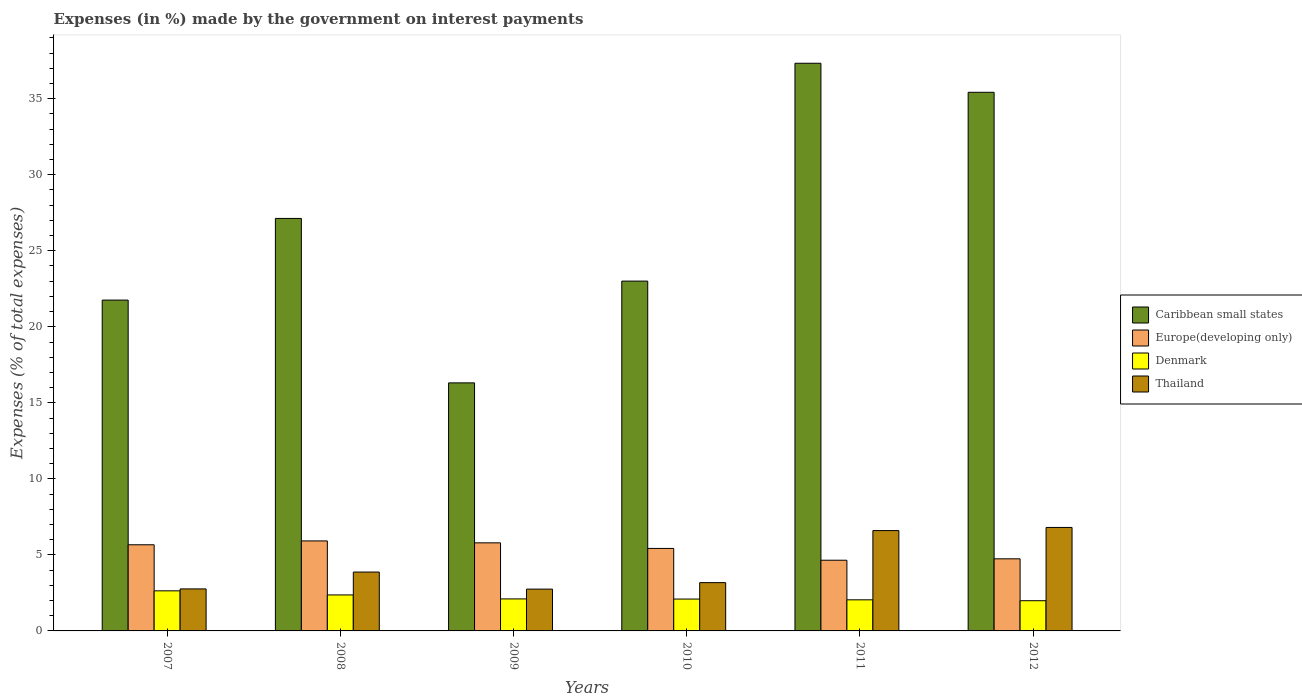How many different coloured bars are there?
Give a very brief answer. 4. Are the number of bars per tick equal to the number of legend labels?
Your response must be concise. Yes. Are the number of bars on each tick of the X-axis equal?
Your answer should be very brief. Yes. In how many cases, is the number of bars for a given year not equal to the number of legend labels?
Your answer should be compact. 0. What is the percentage of expenses made by the government on interest payments in Thailand in 2011?
Provide a short and direct response. 6.6. Across all years, what is the maximum percentage of expenses made by the government on interest payments in Denmark?
Offer a very short reply. 2.64. Across all years, what is the minimum percentage of expenses made by the government on interest payments in Denmark?
Keep it short and to the point. 1.99. In which year was the percentage of expenses made by the government on interest payments in Caribbean small states maximum?
Your response must be concise. 2011. What is the total percentage of expenses made by the government on interest payments in Europe(developing only) in the graph?
Make the answer very short. 32.19. What is the difference between the percentage of expenses made by the government on interest payments in Caribbean small states in 2008 and that in 2012?
Offer a very short reply. -8.29. What is the difference between the percentage of expenses made by the government on interest payments in Caribbean small states in 2007 and the percentage of expenses made by the government on interest payments in Europe(developing only) in 2009?
Ensure brevity in your answer.  15.96. What is the average percentage of expenses made by the government on interest payments in Caribbean small states per year?
Offer a very short reply. 26.83. In the year 2008, what is the difference between the percentage of expenses made by the government on interest payments in Europe(developing only) and percentage of expenses made by the government on interest payments in Denmark?
Your answer should be very brief. 3.55. In how many years, is the percentage of expenses made by the government on interest payments in Denmark greater than 34 %?
Provide a succinct answer. 0. What is the ratio of the percentage of expenses made by the government on interest payments in Europe(developing only) in 2007 to that in 2012?
Provide a short and direct response. 1.19. Is the percentage of expenses made by the government on interest payments in Europe(developing only) in 2008 less than that in 2009?
Offer a very short reply. No. What is the difference between the highest and the second highest percentage of expenses made by the government on interest payments in Denmark?
Your answer should be very brief. 0.27. What is the difference between the highest and the lowest percentage of expenses made by the government on interest payments in Caribbean small states?
Your response must be concise. 21.02. In how many years, is the percentage of expenses made by the government on interest payments in Europe(developing only) greater than the average percentage of expenses made by the government on interest payments in Europe(developing only) taken over all years?
Provide a succinct answer. 4. Is it the case that in every year, the sum of the percentage of expenses made by the government on interest payments in Caribbean small states and percentage of expenses made by the government on interest payments in Denmark is greater than the sum of percentage of expenses made by the government on interest payments in Thailand and percentage of expenses made by the government on interest payments in Europe(developing only)?
Give a very brief answer. Yes. What does the 3rd bar from the right in 2007 represents?
Offer a terse response. Europe(developing only). Is it the case that in every year, the sum of the percentage of expenses made by the government on interest payments in Thailand and percentage of expenses made by the government on interest payments in Denmark is greater than the percentage of expenses made by the government on interest payments in Europe(developing only)?
Make the answer very short. No. Are all the bars in the graph horizontal?
Give a very brief answer. No. How many years are there in the graph?
Offer a terse response. 6. Does the graph contain any zero values?
Your answer should be very brief. No. Where does the legend appear in the graph?
Ensure brevity in your answer.  Center right. What is the title of the graph?
Keep it short and to the point. Expenses (in %) made by the government on interest payments. Does "Malaysia" appear as one of the legend labels in the graph?
Make the answer very short. No. What is the label or title of the X-axis?
Ensure brevity in your answer.  Years. What is the label or title of the Y-axis?
Your answer should be very brief. Expenses (% of total expenses). What is the Expenses (% of total expenses) of Caribbean small states in 2007?
Keep it short and to the point. 21.76. What is the Expenses (% of total expenses) in Europe(developing only) in 2007?
Keep it short and to the point. 5.66. What is the Expenses (% of total expenses) in Denmark in 2007?
Provide a succinct answer. 2.64. What is the Expenses (% of total expenses) in Thailand in 2007?
Your answer should be very brief. 2.76. What is the Expenses (% of total expenses) of Caribbean small states in 2008?
Ensure brevity in your answer.  27.13. What is the Expenses (% of total expenses) of Europe(developing only) in 2008?
Make the answer very short. 5.92. What is the Expenses (% of total expenses) of Denmark in 2008?
Your answer should be very brief. 2.37. What is the Expenses (% of total expenses) of Thailand in 2008?
Provide a succinct answer. 3.87. What is the Expenses (% of total expenses) in Caribbean small states in 2009?
Offer a very short reply. 16.31. What is the Expenses (% of total expenses) of Europe(developing only) in 2009?
Ensure brevity in your answer.  5.79. What is the Expenses (% of total expenses) in Denmark in 2009?
Give a very brief answer. 2.1. What is the Expenses (% of total expenses) of Thailand in 2009?
Provide a succinct answer. 2.75. What is the Expenses (% of total expenses) in Caribbean small states in 2010?
Keep it short and to the point. 23.01. What is the Expenses (% of total expenses) in Europe(developing only) in 2010?
Offer a terse response. 5.42. What is the Expenses (% of total expenses) in Denmark in 2010?
Keep it short and to the point. 2.1. What is the Expenses (% of total expenses) of Thailand in 2010?
Provide a short and direct response. 3.18. What is the Expenses (% of total expenses) in Caribbean small states in 2011?
Your answer should be very brief. 37.33. What is the Expenses (% of total expenses) of Europe(developing only) in 2011?
Keep it short and to the point. 4.65. What is the Expenses (% of total expenses) in Denmark in 2011?
Keep it short and to the point. 2.04. What is the Expenses (% of total expenses) of Thailand in 2011?
Your answer should be compact. 6.6. What is the Expenses (% of total expenses) of Caribbean small states in 2012?
Ensure brevity in your answer.  35.42. What is the Expenses (% of total expenses) of Europe(developing only) in 2012?
Give a very brief answer. 4.74. What is the Expenses (% of total expenses) of Denmark in 2012?
Provide a short and direct response. 1.99. What is the Expenses (% of total expenses) of Thailand in 2012?
Keep it short and to the point. 6.81. Across all years, what is the maximum Expenses (% of total expenses) of Caribbean small states?
Your response must be concise. 37.33. Across all years, what is the maximum Expenses (% of total expenses) in Europe(developing only)?
Offer a very short reply. 5.92. Across all years, what is the maximum Expenses (% of total expenses) in Denmark?
Give a very brief answer. 2.64. Across all years, what is the maximum Expenses (% of total expenses) in Thailand?
Your response must be concise. 6.81. Across all years, what is the minimum Expenses (% of total expenses) in Caribbean small states?
Your answer should be very brief. 16.31. Across all years, what is the minimum Expenses (% of total expenses) in Europe(developing only)?
Offer a very short reply. 4.65. Across all years, what is the minimum Expenses (% of total expenses) in Denmark?
Provide a succinct answer. 1.99. Across all years, what is the minimum Expenses (% of total expenses) in Thailand?
Keep it short and to the point. 2.75. What is the total Expenses (% of total expenses) of Caribbean small states in the graph?
Your answer should be very brief. 160.95. What is the total Expenses (% of total expenses) of Europe(developing only) in the graph?
Keep it short and to the point. 32.19. What is the total Expenses (% of total expenses) of Denmark in the graph?
Give a very brief answer. 13.23. What is the total Expenses (% of total expenses) in Thailand in the graph?
Make the answer very short. 25.96. What is the difference between the Expenses (% of total expenses) of Caribbean small states in 2007 and that in 2008?
Offer a terse response. -5.37. What is the difference between the Expenses (% of total expenses) of Europe(developing only) in 2007 and that in 2008?
Ensure brevity in your answer.  -0.25. What is the difference between the Expenses (% of total expenses) of Denmark in 2007 and that in 2008?
Give a very brief answer. 0.27. What is the difference between the Expenses (% of total expenses) in Thailand in 2007 and that in 2008?
Keep it short and to the point. -1.11. What is the difference between the Expenses (% of total expenses) of Caribbean small states in 2007 and that in 2009?
Offer a terse response. 5.44. What is the difference between the Expenses (% of total expenses) in Europe(developing only) in 2007 and that in 2009?
Your response must be concise. -0.13. What is the difference between the Expenses (% of total expenses) in Denmark in 2007 and that in 2009?
Ensure brevity in your answer.  0.53. What is the difference between the Expenses (% of total expenses) in Thailand in 2007 and that in 2009?
Make the answer very short. 0.01. What is the difference between the Expenses (% of total expenses) in Caribbean small states in 2007 and that in 2010?
Keep it short and to the point. -1.25. What is the difference between the Expenses (% of total expenses) of Europe(developing only) in 2007 and that in 2010?
Offer a very short reply. 0.24. What is the difference between the Expenses (% of total expenses) of Denmark in 2007 and that in 2010?
Offer a very short reply. 0.54. What is the difference between the Expenses (% of total expenses) in Thailand in 2007 and that in 2010?
Ensure brevity in your answer.  -0.41. What is the difference between the Expenses (% of total expenses) of Caribbean small states in 2007 and that in 2011?
Keep it short and to the point. -15.57. What is the difference between the Expenses (% of total expenses) of Europe(developing only) in 2007 and that in 2011?
Make the answer very short. 1.02. What is the difference between the Expenses (% of total expenses) of Denmark in 2007 and that in 2011?
Your response must be concise. 0.59. What is the difference between the Expenses (% of total expenses) in Thailand in 2007 and that in 2011?
Provide a short and direct response. -3.84. What is the difference between the Expenses (% of total expenses) of Caribbean small states in 2007 and that in 2012?
Your answer should be very brief. -13.66. What is the difference between the Expenses (% of total expenses) in Europe(developing only) in 2007 and that in 2012?
Provide a succinct answer. 0.92. What is the difference between the Expenses (% of total expenses) in Denmark in 2007 and that in 2012?
Offer a terse response. 0.65. What is the difference between the Expenses (% of total expenses) in Thailand in 2007 and that in 2012?
Ensure brevity in your answer.  -4.04. What is the difference between the Expenses (% of total expenses) of Caribbean small states in 2008 and that in 2009?
Give a very brief answer. 10.81. What is the difference between the Expenses (% of total expenses) of Europe(developing only) in 2008 and that in 2009?
Provide a succinct answer. 0.13. What is the difference between the Expenses (% of total expenses) of Denmark in 2008 and that in 2009?
Keep it short and to the point. 0.26. What is the difference between the Expenses (% of total expenses) of Thailand in 2008 and that in 2009?
Make the answer very short. 1.12. What is the difference between the Expenses (% of total expenses) of Caribbean small states in 2008 and that in 2010?
Provide a succinct answer. 4.12. What is the difference between the Expenses (% of total expenses) in Europe(developing only) in 2008 and that in 2010?
Give a very brief answer. 0.5. What is the difference between the Expenses (% of total expenses) in Denmark in 2008 and that in 2010?
Give a very brief answer. 0.27. What is the difference between the Expenses (% of total expenses) in Thailand in 2008 and that in 2010?
Keep it short and to the point. 0.7. What is the difference between the Expenses (% of total expenses) in Caribbean small states in 2008 and that in 2011?
Offer a very short reply. -10.2. What is the difference between the Expenses (% of total expenses) in Europe(developing only) in 2008 and that in 2011?
Your answer should be very brief. 1.27. What is the difference between the Expenses (% of total expenses) of Denmark in 2008 and that in 2011?
Make the answer very short. 0.32. What is the difference between the Expenses (% of total expenses) of Thailand in 2008 and that in 2011?
Make the answer very short. -2.73. What is the difference between the Expenses (% of total expenses) in Caribbean small states in 2008 and that in 2012?
Make the answer very short. -8.29. What is the difference between the Expenses (% of total expenses) of Europe(developing only) in 2008 and that in 2012?
Give a very brief answer. 1.18. What is the difference between the Expenses (% of total expenses) in Denmark in 2008 and that in 2012?
Your response must be concise. 0.38. What is the difference between the Expenses (% of total expenses) of Thailand in 2008 and that in 2012?
Provide a succinct answer. -2.93. What is the difference between the Expenses (% of total expenses) in Caribbean small states in 2009 and that in 2010?
Offer a terse response. -6.69. What is the difference between the Expenses (% of total expenses) of Europe(developing only) in 2009 and that in 2010?
Make the answer very short. 0.37. What is the difference between the Expenses (% of total expenses) of Denmark in 2009 and that in 2010?
Offer a terse response. 0.01. What is the difference between the Expenses (% of total expenses) of Thailand in 2009 and that in 2010?
Provide a succinct answer. -0.43. What is the difference between the Expenses (% of total expenses) in Caribbean small states in 2009 and that in 2011?
Ensure brevity in your answer.  -21.02. What is the difference between the Expenses (% of total expenses) in Europe(developing only) in 2009 and that in 2011?
Your response must be concise. 1.14. What is the difference between the Expenses (% of total expenses) of Thailand in 2009 and that in 2011?
Provide a succinct answer. -3.85. What is the difference between the Expenses (% of total expenses) in Caribbean small states in 2009 and that in 2012?
Offer a terse response. -19.11. What is the difference between the Expenses (% of total expenses) of Europe(developing only) in 2009 and that in 2012?
Your response must be concise. 1.05. What is the difference between the Expenses (% of total expenses) of Denmark in 2009 and that in 2012?
Ensure brevity in your answer.  0.12. What is the difference between the Expenses (% of total expenses) of Thailand in 2009 and that in 2012?
Offer a terse response. -4.06. What is the difference between the Expenses (% of total expenses) in Caribbean small states in 2010 and that in 2011?
Offer a very short reply. -14.33. What is the difference between the Expenses (% of total expenses) of Europe(developing only) in 2010 and that in 2011?
Provide a succinct answer. 0.78. What is the difference between the Expenses (% of total expenses) in Denmark in 2010 and that in 2011?
Your answer should be very brief. 0.05. What is the difference between the Expenses (% of total expenses) of Thailand in 2010 and that in 2011?
Give a very brief answer. -3.42. What is the difference between the Expenses (% of total expenses) in Caribbean small states in 2010 and that in 2012?
Provide a short and direct response. -12.42. What is the difference between the Expenses (% of total expenses) of Europe(developing only) in 2010 and that in 2012?
Provide a short and direct response. 0.68. What is the difference between the Expenses (% of total expenses) of Denmark in 2010 and that in 2012?
Offer a very short reply. 0.11. What is the difference between the Expenses (% of total expenses) of Thailand in 2010 and that in 2012?
Your answer should be compact. -3.63. What is the difference between the Expenses (% of total expenses) of Caribbean small states in 2011 and that in 2012?
Provide a succinct answer. 1.91. What is the difference between the Expenses (% of total expenses) of Europe(developing only) in 2011 and that in 2012?
Make the answer very short. -0.09. What is the difference between the Expenses (% of total expenses) in Denmark in 2011 and that in 2012?
Offer a very short reply. 0.06. What is the difference between the Expenses (% of total expenses) in Thailand in 2011 and that in 2012?
Your answer should be compact. -0.21. What is the difference between the Expenses (% of total expenses) of Caribbean small states in 2007 and the Expenses (% of total expenses) of Europe(developing only) in 2008?
Provide a short and direct response. 15.84. What is the difference between the Expenses (% of total expenses) of Caribbean small states in 2007 and the Expenses (% of total expenses) of Denmark in 2008?
Offer a terse response. 19.39. What is the difference between the Expenses (% of total expenses) in Caribbean small states in 2007 and the Expenses (% of total expenses) in Thailand in 2008?
Your response must be concise. 17.89. What is the difference between the Expenses (% of total expenses) of Europe(developing only) in 2007 and the Expenses (% of total expenses) of Denmark in 2008?
Give a very brief answer. 3.3. What is the difference between the Expenses (% of total expenses) of Europe(developing only) in 2007 and the Expenses (% of total expenses) of Thailand in 2008?
Make the answer very short. 1.79. What is the difference between the Expenses (% of total expenses) of Denmark in 2007 and the Expenses (% of total expenses) of Thailand in 2008?
Give a very brief answer. -1.24. What is the difference between the Expenses (% of total expenses) of Caribbean small states in 2007 and the Expenses (% of total expenses) of Europe(developing only) in 2009?
Keep it short and to the point. 15.96. What is the difference between the Expenses (% of total expenses) of Caribbean small states in 2007 and the Expenses (% of total expenses) of Denmark in 2009?
Keep it short and to the point. 19.65. What is the difference between the Expenses (% of total expenses) in Caribbean small states in 2007 and the Expenses (% of total expenses) in Thailand in 2009?
Offer a very short reply. 19.01. What is the difference between the Expenses (% of total expenses) of Europe(developing only) in 2007 and the Expenses (% of total expenses) of Denmark in 2009?
Offer a terse response. 3.56. What is the difference between the Expenses (% of total expenses) in Europe(developing only) in 2007 and the Expenses (% of total expenses) in Thailand in 2009?
Provide a succinct answer. 2.92. What is the difference between the Expenses (% of total expenses) of Denmark in 2007 and the Expenses (% of total expenses) of Thailand in 2009?
Offer a terse response. -0.11. What is the difference between the Expenses (% of total expenses) in Caribbean small states in 2007 and the Expenses (% of total expenses) in Europe(developing only) in 2010?
Keep it short and to the point. 16.33. What is the difference between the Expenses (% of total expenses) in Caribbean small states in 2007 and the Expenses (% of total expenses) in Denmark in 2010?
Offer a very short reply. 19.66. What is the difference between the Expenses (% of total expenses) of Caribbean small states in 2007 and the Expenses (% of total expenses) of Thailand in 2010?
Keep it short and to the point. 18.58. What is the difference between the Expenses (% of total expenses) of Europe(developing only) in 2007 and the Expenses (% of total expenses) of Denmark in 2010?
Make the answer very short. 3.57. What is the difference between the Expenses (% of total expenses) in Europe(developing only) in 2007 and the Expenses (% of total expenses) in Thailand in 2010?
Offer a terse response. 2.49. What is the difference between the Expenses (% of total expenses) of Denmark in 2007 and the Expenses (% of total expenses) of Thailand in 2010?
Ensure brevity in your answer.  -0.54. What is the difference between the Expenses (% of total expenses) in Caribbean small states in 2007 and the Expenses (% of total expenses) in Europe(developing only) in 2011?
Keep it short and to the point. 17.11. What is the difference between the Expenses (% of total expenses) of Caribbean small states in 2007 and the Expenses (% of total expenses) of Denmark in 2011?
Provide a short and direct response. 19.71. What is the difference between the Expenses (% of total expenses) of Caribbean small states in 2007 and the Expenses (% of total expenses) of Thailand in 2011?
Offer a very short reply. 15.16. What is the difference between the Expenses (% of total expenses) of Europe(developing only) in 2007 and the Expenses (% of total expenses) of Denmark in 2011?
Offer a very short reply. 3.62. What is the difference between the Expenses (% of total expenses) of Europe(developing only) in 2007 and the Expenses (% of total expenses) of Thailand in 2011?
Keep it short and to the point. -0.93. What is the difference between the Expenses (% of total expenses) in Denmark in 2007 and the Expenses (% of total expenses) in Thailand in 2011?
Your answer should be compact. -3.96. What is the difference between the Expenses (% of total expenses) of Caribbean small states in 2007 and the Expenses (% of total expenses) of Europe(developing only) in 2012?
Your answer should be very brief. 17.01. What is the difference between the Expenses (% of total expenses) in Caribbean small states in 2007 and the Expenses (% of total expenses) in Denmark in 2012?
Offer a very short reply. 19.77. What is the difference between the Expenses (% of total expenses) of Caribbean small states in 2007 and the Expenses (% of total expenses) of Thailand in 2012?
Make the answer very short. 14.95. What is the difference between the Expenses (% of total expenses) in Europe(developing only) in 2007 and the Expenses (% of total expenses) in Denmark in 2012?
Your answer should be very brief. 3.68. What is the difference between the Expenses (% of total expenses) of Europe(developing only) in 2007 and the Expenses (% of total expenses) of Thailand in 2012?
Give a very brief answer. -1.14. What is the difference between the Expenses (% of total expenses) of Denmark in 2007 and the Expenses (% of total expenses) of Thailand in 2012?
Provide a short and direct response. -4.17. What is the difference between the Expenses (% of total expenses) in Caribbean small states in 2008 and the Expenses (% of total expenses) in Europe(developing only) in 2009?
Keep it short and to the point. 21.33. What is the difference between the Expenses (% of total expenses) of Caribbean small states in 2008 and the Expenses (% of total expenses) of Denmark in 2009?
Provide a succinct answer. 25.02. What is the difference between the Expenses (% of total expenses) of Caribbean small states in 2008 and the Expenses (% of total expenses) of Thailand in 2009?
Provide a succinct answer. 24.38. What is the difference between the Expenses (% of total expenses) in Europe(developing only) in 2008 and the Expenses (% of total expenses) in Denmark in 2009?
Ensure brevity in your answer.  3.81. What is the difference between the Expenses (% of total expenses) in Europe(developing only) in 2008 and the Expenses (% of total expenses) in Thailand in 2009?
Provide a succinct answer. 3.17. What is the difference between the Expenses (% of total expenses) in Denmark in 2008 and the Expenses (% of total expenses) in Thailand in 2009?
Ensure brevity in your answer.  -0.38. What is the difference between the Expenses (% of total expenses) in Caribbean small states in 2008 and the Expenses (% of total expenses) in Europe(developing only) in 2010?
Ensure brevity in your answer.  21.7. What is the difference between the Expenses (% of total expenses) of Caribbean small states in 2008 and the Expenses (% of total expenses) of Denmark in 2010?
Ensure brevity in your answer.  25.03. What is the difference between the Expenses (% of total expenses) in Caribbean small states in 2008 and the Expenses (% of total expenses) in Thailand in 2010?
Give a very brief answer. 23.95. What is the difference between the Expenses (% of total expenses) in Europe(developing only) in 2008 and the Expenses (% of total expenses) in Denmark in 2010?
Your answer should be compact. 3.82. What is the difference between the Expenses (% of total expenses) of Europe(developing only) in 2008 and the Expenses (% of total expenses) of Thailand in 2010?
Your response must be concise. 2.74. What is the difference between the Expenses (% of total expenses) in Denmark in 2008 and the Expenses (% of total expenses) in Thailand in 2010?
Ensure brevity in your answer.  -0.81. What is the difference between the Expenses (% of total expenses) of Caribbean small states in 2008 and the Expenses (% of total expenses) of Europe(developing only) in 2011?
Provide a succinct answer. 22.48. What is the difference between the Expenses (% of total expenses) of Caribbean small states in 2008 and the Expenses (% of total expenses) of Denmark in 2011?
Make the answer very short. 25.08. What is the difference between the Expenses (% of total expenses) in Caribbean small states in 2008 and the Expenses (% of total expenses) in Thailand in 2011?
Your answer should be compact. 20.53. What is the difference between the Expenses (% of total expenses) of Europe(developing only) in 2008 and the Expenses (% of total expenses) of Denmark in 2011?
Keep it short and to the point. 3.87. What is the difference between the Expenses (% of total expenses) in Europe(developing only) in 2008 and the Expenses (% of total expenses) in Thailand in 2011?
Make the answer very short. -0.68. What is the difference between the Expenses (% of total expenses) in Denmark in 2008 and the Expenses (% of total expenses) in Thailand in 2011?
Give a very brief answer. -4.23. What is the difference between the Expenses (% of total expenses) in Caribbean small states in 2008 and the Expenses (% of total expenses) in Europe(developing only) in 2012?
Give a very brief answer. 22.38. What is the difference between the Expenses (% of total expenses) of Caribbean small states in 2008 and the Expenses (% of total expenses) of Denmark in 2012?
Your answer should be very brief. 25.14. What is the difference between the Expenses (% of total expenses) in Caribbean small states in 2008 and the Expenses (% of total expenses) in Thailand in 2012?
Give a very brief answer. 20.32. What is the difference between the Expenses (% of total expenses) of Europe(developing only) in 2008 and the Expenses (% of total expenses) of Denmark in 2012?
Your answer should be very brief. 3.93. What is the difference between the Expenses (% of total expenses) of Europe(developing only) in 2008 and the Expenses (% of total expenses) of Thailand in 2012?
Keep it short and to the point. -0.89. What is the difference between the Expenses (% of total expenses) in Denmark in 2008 and the Expenses (% of total expenses) in Thailand in 2012?
Offer a terse response. -4.44. What is the difference between the Expenses (% of total expenses) in Caribbean small states in 2009 and the Expenses (% of total expenses) in Europe(developing only) in 2010?
Offer a terse response. 10.89. What is the difference between the Expenses (% of total expenses) in Caribbean small states in 2009 and the Expenses (% of total expenses) in Denmark in 2010?
Ensure brevity in your answer.  14.22. What is the difference between the Expenses (% of total expenses) in Caribbean small states in 2009 and the Expenses (% of total expenses) in Thailand in 2010?
Provide a short and direct response. 13.14. What is the difference between the Expenses (% of total expenses) in Europe(developing only) in 2009 and the Expenses (% of total expenses) in Denmark in 2010?
Make the answer very short. 3.7. What is the difference between the Expenses (% of total expenses) in Europe(developing only) in 2009 and the Expenses (% of total expenses) in Thailand in 2010?
Make the answer very short. 2.62. What is the difference between the Expenses (% of total expenses) of Denmark in 2009 and the Expenses (% of total expenses) of Thailand in 2010?
Ensure brevity in your answer.  -1.07. What is the difference between the Expenses (% of total expenses) of Caribbean small states in 2009 and the Expenses (% of total expenses) of Europe(developing only) in 2011?
Offer a very short reply. 11.66. What is the difference between the Expenses (% of total expenses) in Caribbean small states in 2009 and the Expenses (% of total expenses) in Denmark in 2011?
Provide a short and direct response. 14.27. What is the difference between the Expenses (% of total expenses) of Caribbean small states in 2009 and the Expenses (% of total expenses) of Thailand in 2011?
Provide a succinct answer. 9.71. What is the difference between the Expenses (% of total expenses) of Europe(developing only) in 2009 and the Expenses (% of total expenses) of Denmark in 2011?
Your answer should be compact. 3.75. What is the difference between the Expenses (% of total expenses) of Europe(developing only) in 2009 and the Expenses (% of total expenses) of Thailand in 2011?
Offer a terse response. -0.81. What is the difference between the Expenses (% of total expenses) in Denmark in 2009 and the Expenses (% of total expenses) in Thailand in 2011?
Offer a terse response. -4.49. What is the difference between the Expenses (% of total expenses) in Caribbean small states in 2009 and the Expenses (% of total expenses) in Europe(developing only) in 2012?
Make the answer very short. 11.57. What is the difference between the Expenses (% of total expenses) in Caribbean small states in 2009 and the Expenses (% of total expenses) in Denmark in 2012?
Offer a terse response. 14.33. What is the difference between the Expenses (% of total expenses) in Caribbean small states in 2009 and the Expenses (% of total expenses) in Thailand in 2012?
Provide a succinct answer. 9.51. What is the difference between the Expenses (% of total expenses) of Europe(developing only) in 2009 and the Expenses (% of total expenses) of Denmark in 2012?
Your response must be concise. 3.81. What is the difference between the Expenses (% of total expenses) in Europe(developing only) in 2009 and the Expenses (% of total expenses) in Thailand in 2012?
Ensure brevity in your answer.  -1.01. What is the difference between the Expenses (% of total expenses) of Denmark in 2009 and the Expenses (% of total expenses) of Thailand in 2012?
Keep it short and to the point. -4.7. What is the difference between the Expenses (% of total expenses) of Caribbean small states in 2010 and the Expenses (% of total expenses) of Europe(developing only) in 2011?
Ensure brevity in your answer.  18.36. What is the difference between the Expenses (% of total expenses) in Caribbean small states in 2010 and the Expenses (% of total expenses) in Denmark in 2011?
Offer a very short reply. 20.96. What is the difference between the Expenses (% of total expenses) in Caribbean small states in 2010 and the Expenses (% of total expenses) in Thailand in 2011?
Provide a succinct answer. 16.41. What is the difference between the Expenses (% of total expenses) of Europe(developing only) in 2010 and the Expenses (% of total expenses) of Denmark in 2011?
Give a very brief answer. 3.38. What is the difference between the Expenses (% of total expenses) in Europe(developing only) in 2010 and the Expenses (% of total expenses) in Thailand in 2011?
Your answer should be compact. -1.17. What is the difference between the Expenses (% of total expenses) in Denmark in 2010 and the Expenses (% of total expenses) in Thailand in 2011?
Provide a succinct answer. -4.5. What is the difference between the Expenses (% of total expenses) of Caribbean small states in 2010 and the Expenses (% of total expenses) of Europe(developing only) in 2012?
Ensure brevity in your answer.  18.26. What is the difference between the Expenses (% of total expenses) in Caribbean small states in 2010 and the Expenses (% of total expenses) in Denmark in 2012?
Offer a very short reply. 21.02. What is the difference between the Expenses (% of total expenses) of Caribbean small states in 2010 and the Expenses (% of total expenses) of Thailand in 2012?
Your answer should be very brief. 16.2. What is the difference between the Expenses (% of total expenses) of Europe(developing only) in 2010 and the Expenses (% of total expenses) of Denmark in 2012?
Your answer should be very brief. 3.44. What is the difference between the Expenses (% of total expenses) in Europe(developing only) in 2010 and the Expenses (% of total expenses) in Thailand in 2012?
Provide a succinct answer. -1.38. What is the difference between the Expenses (% of total expenses) in Denmark in 2010 and the Expenses (% of total expenses) in Thailand in 2012?
Provide a succinct answer. -4.71. What is the difference between the Expenses (% of total expenses) in Caribbean small states in 2011 and the Expenses (% of total expenses) in Europe(developing only) in 2012?
Your answer should be very brief. 32.59. What is the difference between the Expenses (% of total expenses) of Caribbean small states in 2011 and the Expenses (% of total expenses) of Denmark in 2012?
Keep it short and to the point. 35.34. What is the difference between the Expenses (% of total expenses) of Caribbean small states in 2011 and the Expenses (% of total expenses) of Thailand in 2012?
Give a very brief answer. 30.53. What is the difference between the Expenses (% of total expenses) in Europe(developing only) in 2011 and the Expenses (% of total expenses) in Denmark in 2012?
Give a very brief answer. 2.66. What is the difference between the Expenses (% of total expenses) of Europe(developing only) in 2011 and the Expenses (% of total expenses) of Thailand in 2012?
Offer a very short reply. -2.16. What is the difference between the Expenses (% of total expenses) of Denmark in 2011 and the Expenses (% of total expenses) of Thailand in 2012?
Give a very brief answer. -4.76. What is the average Expenses (% of total expenses) of Caribbean small states per year?
Offer a very short reply. 26.83. What is the average Expenses (% of total expenses) of Europe(developing only) per year?
Provide a succinct answer. 5.37. What is the average Expenses (% of total expenses) in Denmark per year?
Ensure brevity in your answer.  2.21. What is the average Expenses (% of total expenses) of Thailand per year?
Give a very brief answer. 4.33. In the year 2007, what is the difference between the Expenses (% of total expenses) in Caribbean small states and Expenses (% of total expenses) in Europe(developing only)?
Offer a terse response. 16.09. In the year 2007, what is the difference between the Expenses (% of total expenses) in Caribbean small states and Expenses (% of total expenses) in Denmark?
Provide a succinct answer. 19.12. In the year 2007, what is the difference between the Expenses (% of total expenses) in Caribbean small states and Expenses (% of total expenses) in Thailand?
Your response must be concise. 18.99. In the year 2007, what is the difference between the Expenses (% of total expenses) in Europe(developing only) and Expenses (% of total expenses) in Denmark?
Provide a succinct answer. 3.03. In the year 2007, what is the difference between the Expenses (% of total expenses) in Europe(developing only) and Expenses (% of total expenses) in Thailand?
Give a very brief answer. 2.9. In the year 2007, what is the difference between the Expenses (% of total expenses) of Denmark and Expenses (% of total expenses) of Thailand?
Keep it short and to the point. -0.13. In the year 2008, what is the difference between the Expenses (% of total expenses) of Caribbean small states and Expenses (% of total expenses) of Europe(developing only)?
Your answer should be compact. 21.21. In the year 2008, what is the difference between the Expenses (% of total expenses) of Caribbean small states and Expenses (% of total expenses) of Denmark?
Provide a short and direct response. 24.76. In the year 2008, what is the difference between the Expenses (% of total expenses) in Caribbean small states and Expenses (% of total expenses) in Thailand?
Your answer should be compact. 23.26. In the year 2008, what is the difference between the Expenses (% of total expenses) of Europe(developing only) and Expenses (% of total expenses) of Denmark?
Your answer should be compact. 3.55. In the year 2008, what is the difference between the Expenses (% of total expenses) of Europe(developing only) and Expenses (% of total expenses) of Thailand?
Give a very brief answer. 2.05. In the year 2008, what is the difference between the Expenses (% of total expenses) in Denmark and Expenses (% of total expenses) in Thailand?
Make the answer very short. -1.5. In the year 2009, what is the difference between the Expenses (% of total expenses) in Caribbean small states and Expenses (% of total expenses) in Europe(developing only)?
Your response must be concise. 10.52. In the year 2009, what is the difference between the Expenses (% of total expenses) in Caribbean small states and Expenses (% of total expenses) in Denmark?
Your answer should be very brief. 14.21. In the year 2009, what is the difference between the Expenses (% of total expenses) in Caribbean small states and Expenses (% of total expenses) in Thailand?
Provide a short and direct response. 13.56. In the year 2009, what is the difference between the Expenses (% of total expenses) of Europe(developing only) and Expenses (% of total expenses) of Denmark?
Your response must be concise. 3.69. In the year 2009, what is the difference between the Expenses (% of total expenses) of Europe(developing only) and Expenses (% of total expenses) of Thailand?
Give a very brief answer. 3.04. In the year 2009, what is the difference between the Expenses (% of total expenses) in Denmark and Expenses (% of total expenses) in Thailand?
Ensure brevity in your answer.  -0.64. In the year 2010, what is the difference between the Expenses (% of total expenses) in Caribbean small states and Expenses (% of total expenses) in Europe(developing only)?
Keep it short and to the point. 17.58. In the year 2010, what is the difference between the Expenses (% of total expenses) in Caribbean small states and Expenses (% of total expenses) in Denmark?
Keep it short and to the point. 20.91. In the year 2010, what is the difference between the Expenses (% of total expenses) of Caribbean small states and Expenses (% of total expenses) of Thailand?
Provide a short and direct response. 19.83. In the year 2010, what is the difference between the Expenses (% of total expenses) in Europe(developing only) and Expenses (% of total expenses) in Denmark?
Your answer should be compact. 3.33. In the year 2010, what is the difference between the Expenses (% of total expenses) in Europe(developing only) and Expenses (% of total expenses) in Thailand?
Provide a short and direct response. 2.25. In the year 2010, what is the difference between the Expenses (% of total expenses) in Denmark and Expenses (% of total expenses) in Thailand?
Give a very brief answer. -1.08. In the year 2011, what is the difference between the Expenses (% of total expenses) of Caribbean small states and Expenses (% of total expenses) of Europe(developing only)?
Ensure brevity in your answer.  32.68. In the year 2011, what is the difference between the Expenses (% of total expenses) in Caribbean small states and Expenses (% of total expenses) in Denmark?
Provide a short and direct response. 35.29. In the year 2011, what is the difference between the Expenses (% of total expenses) in Caribbean small states and Expenses (% of total expenses) in Thailand?
Your response must be concise. 30.73. In the year 2011, what is the difference between the Expenses (% of total expenses) in Europe(developing only) and Expenses (% of total expenses) in Denmark?
Offer a very short reply. 2.6. In the year 2011, what is the difference between the Expenses (% of total expenses) in Europe(developing only) and Expenses (% of total expenses) in Thailand?
Offer a very short reply. -1.95. In the year 2011, what is the difference between the Expenses (% of total expenses) of Denmark and Expenses (% of total expenses) of Thailand?
Your answer should be compact. -4.55. In the year 2012, what is the difference between the Expenses (% of total expenses) of Caribbean small states and Expenses (% of total expenses) of Europe(developing only)?
Offer a very short reply. 30.68. In the year 2012, what is the difference between the Expenses (% of total expenses) in Caribbean small states and Expenses (% of total expenses) in Denmark?
Your answer should be compact. 33.43. In the year 2012, what is the difference between the Expenses (% of total expenses) in Caribbean small states and Expenses (% of total expenses) in Thailand?
Provide a short and direct response. 28.62. In the year 2012, what is the difference between the Expenses (% of total expenses) in Europe(developing only) and Expenses (% of total expenses) in Denmark?
Your response must be concise. 2.75. In the year 2012, what is the difference between the Expenses (% of total expenses) of Europe(developing only) and Expenses (% of total expenses) of Thailand?
Offer a very short reply. -2.06. In the year 2012, what is the difference between the Expenses (% of total expenses) in Denmark and Expenses (% of total expenses) in Thailand?
Your answer should be compact. -4.82. What is the ratio of the Expenses (% of total expenses) of Caribbean small states in 2007 to that in 2008?
Keep it short and to the point. 0.8. What is the ratio of the Expenses (% of total expenses) of Denmark in 2007 to that in 2008?
Offer a very short reply. 1.11. What is the ratio of the Expenses (% of total expenses) of Thailand in 2007 to that in 2008?
Your response must be concise. 0.71. What is the ratio of the Expenses (% of total expenses) in Caribbean small states in 2007 to that in 2009?
Your answer should be very brief. 1.33. What is the ratio of the Expenses (% of total expenses) in Europe(developing only) in 2007 to that in 2009?
Keep it short and to the point. 0.98. What is the ratio of the Expenses (% of total expenses) in Denmark in 2007 to that in 2009?
Your answer should be very brief. 1.25. What is the ratio of the Expenses (% of total expenses) of Caribbean small states in 2007 to that in 2010?
Make the answer very short. 0.95. What is the ratio of the Expenses (% of total expenses) of Europe(developing only) in 2007 to that in 2010?
Offer a terse response. 1.04. What is the ratio of the Expenses (% of total expenses) in Denmark in 2007 to that in 2010?
Provide a succinct answer. 1.26. What is the ratio of the Expenses (% of total expenses) of Thailand in 2007 to that in 2010?
Provide a succinct answer. 0.87. What is the ratio of the Expenses (% of total expenses) in Caribbean small states in 2007 to that in 2011?
Your response must be concise. 0.58. What is the ratio of the Expenses (% of total expenses) in Europe(developing only) in 2007 to that in 2011?
Make the answer very short. 1.22. What is the ratio of the Expenses (% of total expenses) in Denmark in 2007 to that in 2011?
Keep it short and to the point. 1.29. What is the ratio of the Expenses (% of total expenses) in Thailand in 2007 to that in 2011?
Ensure brevity in your answer.  0.42. What is the ratio of the Expenses (% of total expenses) of Caribbean small states in 2007 to that in 2012?
Your answer should be compact. 0.61. What is the ratio of the Expenses (% of total expenses) of Europe(developing only) in 2007 to that in 2012?
Keep it short and to the point. 1.19. What is the ratio of the Expenses (% of total expenses) in Denmark in 2007 to that in 2012?
Give a very brief answer. 1.33. What is the ratio of the Expenses (% of total expenses) of Thailand in 2007 to that in 2012?
Provide a succinct answer. 0.41. What is the ratio of the Expenses (% of total expenses) of Caribbean small states in 2008 to that in 2009?
Keep it short and to the point. 1.66. What is the ratio of the Expenses (% of total expenses) of Europe(developing only) in 2008 to that in 2009?
Provide a succinct answer. 1.02. What is the ratio of the Expenses (% of total expenses) in Denmark in 2008 to that in 2009?
Make the answer very short. 1.12. What is the ratio of the Expenses (% of total expenses) of Thailand in 2008 to that in 2009?
Ensure brevity in your answer.  1.41. What is the ratio of the Expenses (% of total expenses) in Caribbean small states in 2008 to that in 2010?
Ensure brevity in your answer.  1.18. What is the ratio of the Expenses (% of total expenses) of Europe(developing only) in 2008 to that in 2010?
Provide a succinct answer. 1.09. What is the ratio of the Expenses (% of total expenses) in Denmark in 2008 to that in 2010?
Offer a terse response. 1.13. What is the ratio of the Expenses (% of total expenses) of Thailand in 2008 to that in 2010?
Provide a succinct answer. 1.22. What is the ratio of the Expenses (% of total expenses) in Caribbean small states in 2008 to that in 2011?
Offer a very short reply. 0.73. What is the ratio of the Expenses (% of total expenses) in Europe(developing only) in 2008 to that in 2011?
Your response must be concise. 1.27. What is the ratio of the Expenses (% of total expenses) of Denmark in 2008 to that in 2011?
Provide a short and direct response. 1.16. What is the ratio of the Expenses (% of total expenses) in Thailand in 2008 to that in 2011?
Keep it short and to the point. 0.59. What is the ratio of the Expenses (% of total expenses) of Caribbean small states in 2008 to that in 2012?
Offer a very short reply. 0.77. What is the ratio of the Expenses (% of total expenses) of Europe(developing only) in 2008 to that in 2012?
Your answer should be compact. 1.25. What is the ratio of the Expenses (% of total expenses) in Denmark in 2008 to that in 2012?
Provide a short and direct response. 1.19. What is the ratio of the Expenses (% of total expenses) in Thailand in 2008 to that in 2012?
Offer a terse response. 0.57. What is the ratio of the Expenses (% of total expenses) of Caribbean small states in 2009 to that in 2010?
Make the answer very short. 0.71. What is the ratio of the Expenses (% of total expenses) of Europe(developing only) in 2009 to that in 2010?
Keep it short and to the point. 1.07. What is the ratio of the Expenses (% of total expenses) of Thailand in 2009 to that in 2010?
Provide a short and direct response. 0.87. What is the ratio of the Expenses (% of total expenses) of Caribbean small states in 2009 to that in 2011?
Offer a very short reply. 0.44. What is the ratio of the Expenses (% of total expenses) in Europe(developing only) in 2009 to that in 2011?
Provide a succinct answer. 1.25. What is the ratio of the Expenses (% of total expenses) of Denmark in 2009 to that in 2011?
Offer a terse response. 1.03. What is the ratio of the Expenses (% of total expenses) in Thailand in 2009 to that in 2011?
Your answer should be compact. 0.42. What is the ratio of the Expenses (% of total expenses) in Caribbean small states in 2009 to that in 2012?
Provide a short and direct response. 0.46. What is the ratio of the Expenses (% of total expenses) in Europe(developing only) in 2009 to that in 2012?
Ensure brevity in your answer.  1.22. What is the ratio of the Expenses (% of total expenses) in Denmark in 2009 to that in 2012?
Provide a succinct answer. 1.06. What is the ratio of the Expenses (% of total expenses) in Thailand in 2009 to that in 2012?
Provide a succinct answer. 0.4. What is the ratio of the Expenses (% of total expenses) of Caribbean small states in 2010 to that in 2011?
Give a very brief answer. 0.62. What is the ratio of the Expenses (% of total expenses) in Europe(developing only) in 2010 to that in 2011?
Offer a very short reply. 1.17. What is the ratio of the Expenses (% of total expenses) in Denmark in 2010 to that in 2011?
Ensure brevity in your answer.  1.02. What is the ratio of the Expenses (% of total expenses) of Thailand in 2010 to that in 2011?
Ensure brevity in your answer.  0.48. What is the ratio of the Expenses (% of total expenses) in Caribbean small states in 2010 to that in 2012?
Offer a terse response. 0.65. What is the ratio of the Expenses (% of total expenses) of Europe(developing only) in 2010 to that in 2012?
Offer a very short reply. 1.14. What is the ratio of the Expenses (% of total expenses) in Denmark in 2010 to that in 2012?
Provide a succinct answer. 1.05. What is the ratio of the Expenses (% of total expenses) of Thailand in 2010 to that in 2012?
Offer a terse response. 0.47. What is the ratio of the Expenses (% of total expenses) in Caribbean small states in 2011 to that in 2012?
Your response must be concise. 1.05. What is the ratio of the Expenses (% of total expenses) of Europe(developing only) in 2011 to that in 2012?
Provide a short and direct response. 0.98. What is the ratio of the Expenses (% of total expenses) of Denmark in 2011 to that in 2012?
Keep it short and to the point. 1.03. What is the ratio of the Expenses (% of total expenses) of Thailand in 2011 to that in 2012?
Provide a succinct answer. 0.97. What is the difference between the highest and the second highest Expenses (% of total expenses) in Caribbean small states?
Your response must be concise. 1.91. What is the difference between the highest and the second highest Expenses (% of total expenses) of Europe(developing only)?
Your answer should be compact. 0.13. What is the difference between the highest and the second highest Expenses (% of total expenses) in Denmark?
Your answer should be very brief. 0.27. What is the difference between the highest and the second highest Expenses (% of total expenses) in Thailand?
Your answer should be compact. 0.21. What is the difference between the highest and the lowest Expenses (% of total expenses) of Caribbean small states?
Your response must be concise. 21.02. What is the difference between the highest and the lowest Expenses (% of total expenses) of Europe(developing only)?
Give a very brief answer. 1.27. What is the difference between the highest and the lowest Expenses (% of total expenses) in Denmark?
Provide a short and direct response. 0.65. What is the difference between the highest and the lowest Expenses (% of total expenses) of Thailand?
Give a very brief answer. 4.06. 